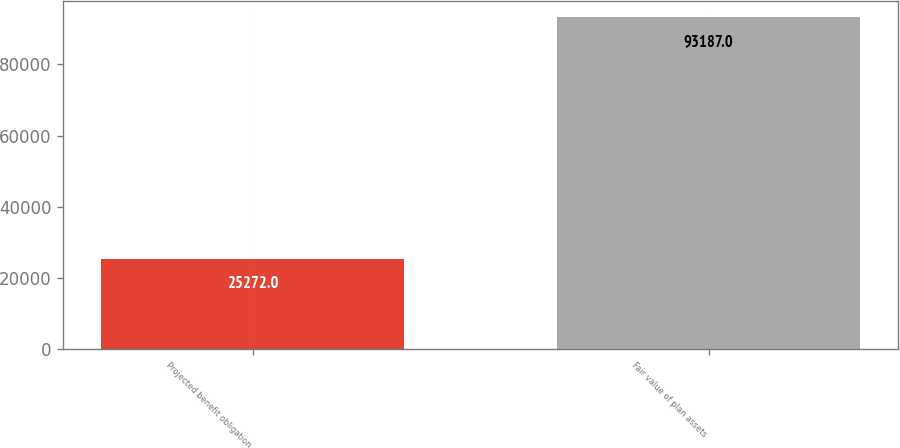<chart> <loc_0><loc_0><loc_500><loc_500><bar_chart><fcel>Projected benefit obligation<fcel>Fair value of plan assets<nl><fcel>25272<fcel>93187<nl></chart> 